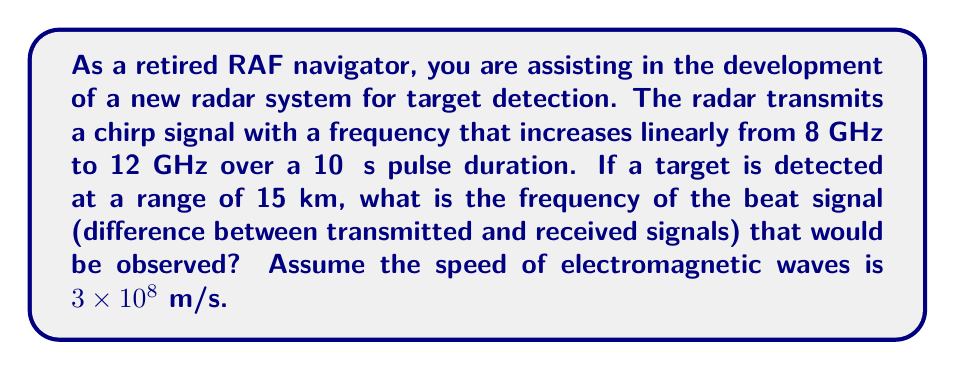Can you answer this question? To solve this problem, we need to use the principles of Fourier transform and radar signal processing. Let's break it down step-by-step:

1) First, we need to calculate the time delay between the transmitted and received signals:

   $t_{delay} = \frac{2 \times \text{Range}}{\text{Speed of EM waves}}$

   $t_{delay} = \frac{2 \times 15,000 \text{ m}}{3 \times 10^8 \text{ m/s}} = 100 \text{ μs}$

2) The chirp rate (rate of frequency change) is:

   $\text{Chirp rate} = \frac{\text{Frequency change}}{\text{Pulse duration}}$

   $\text{Chirp rate} = \frac{12 \text{ GHz} - 8 \text{ GHz}}{10 \text{ μs}} = 0.4 \text{ GHz/μs} = 4 \times 10^{14} \text{ Hz/s}$

3) The beat frequency is the product of the chirp rate and the time delay:

   $f_{beat} = \text{Chirp rate} \times t_{delay}$

   $f_{beat} = (4 \times 10^{14} \text{ Hz/s}) \times (100 \times 10^{-6} \text{ s})$

   $f_{beat} = 4 \times 10^7 \text{ Hz} = 40 \text{ MHz}$

This beat frequency is what would be observed in the radar receiver after mixing the transmitted and received signals. The Fourier transform of this beat signal would show a peak at 40 MHz, indicating the presence of a target at the 15 km range.
Answer: The frequency of the beat signal is 40 MHz. 